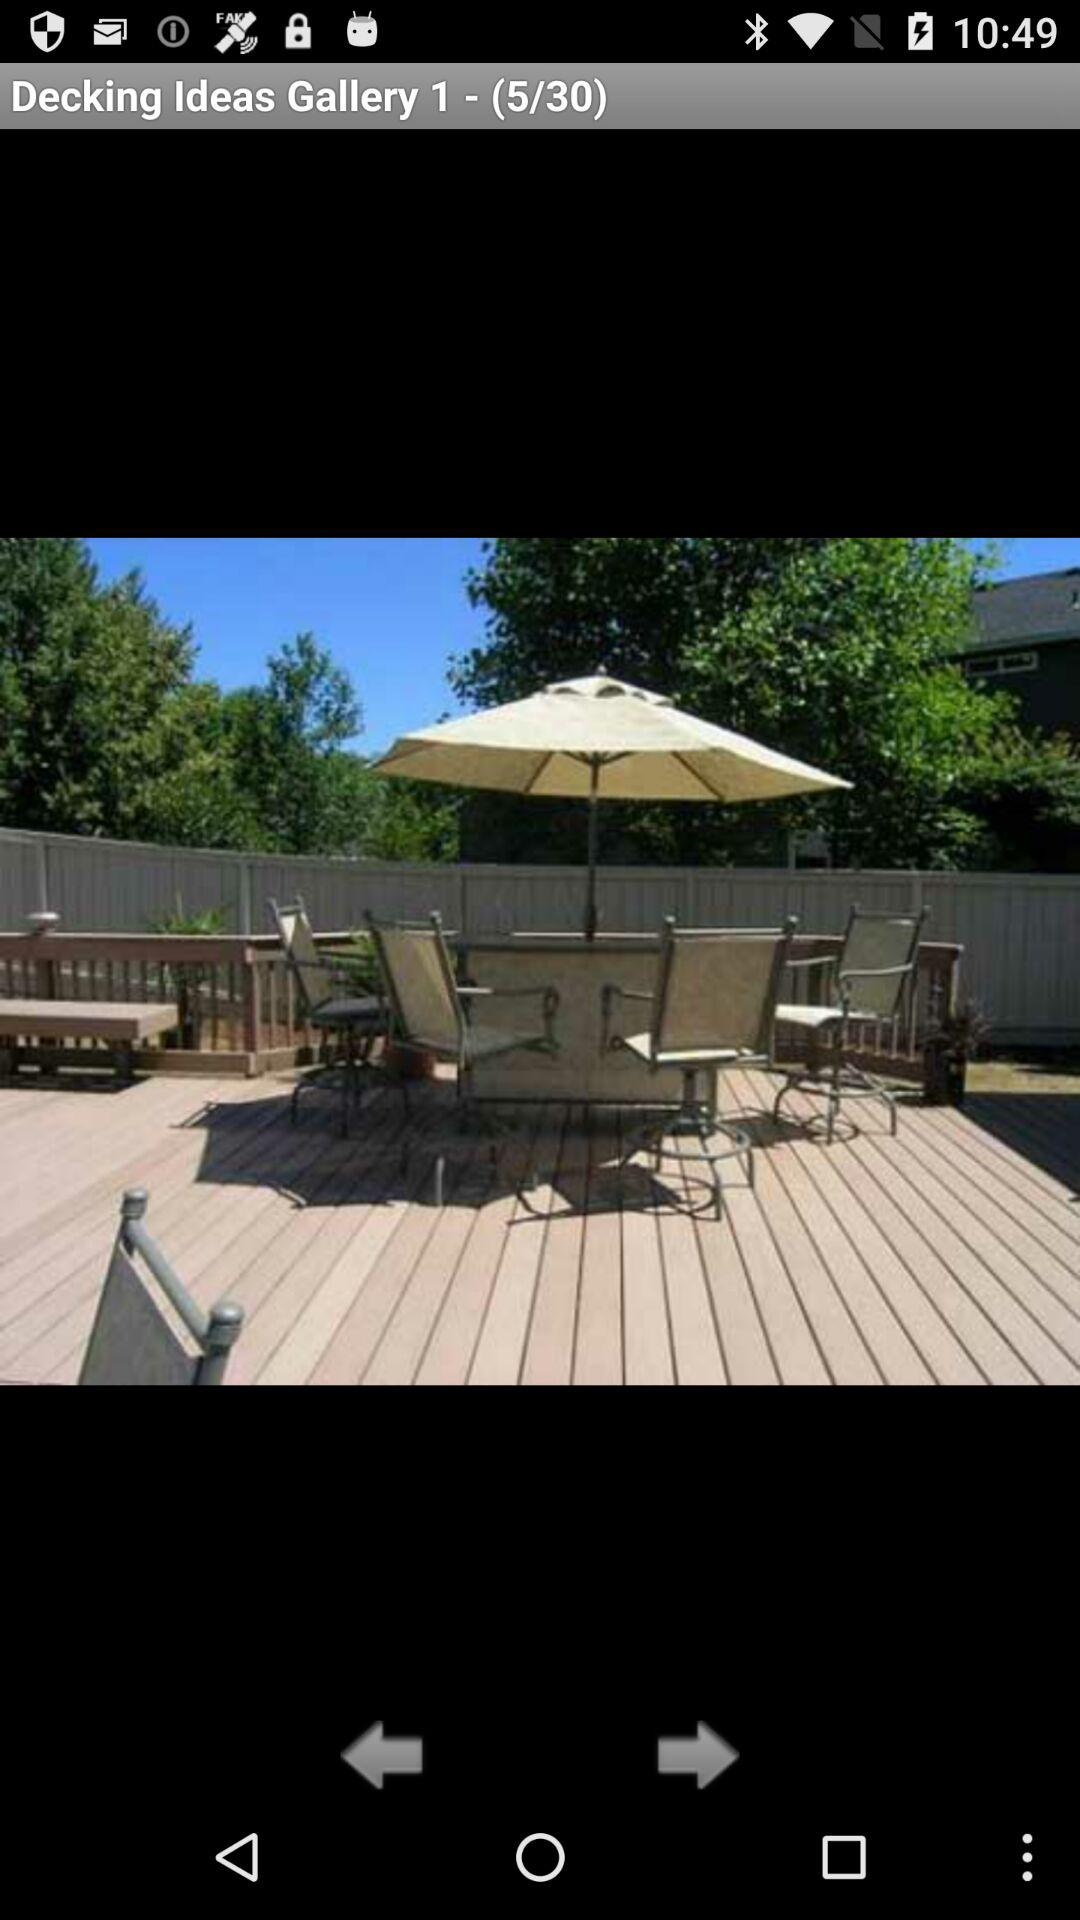Which picture number is the person currently on? The person is currently on the picture number 5. 